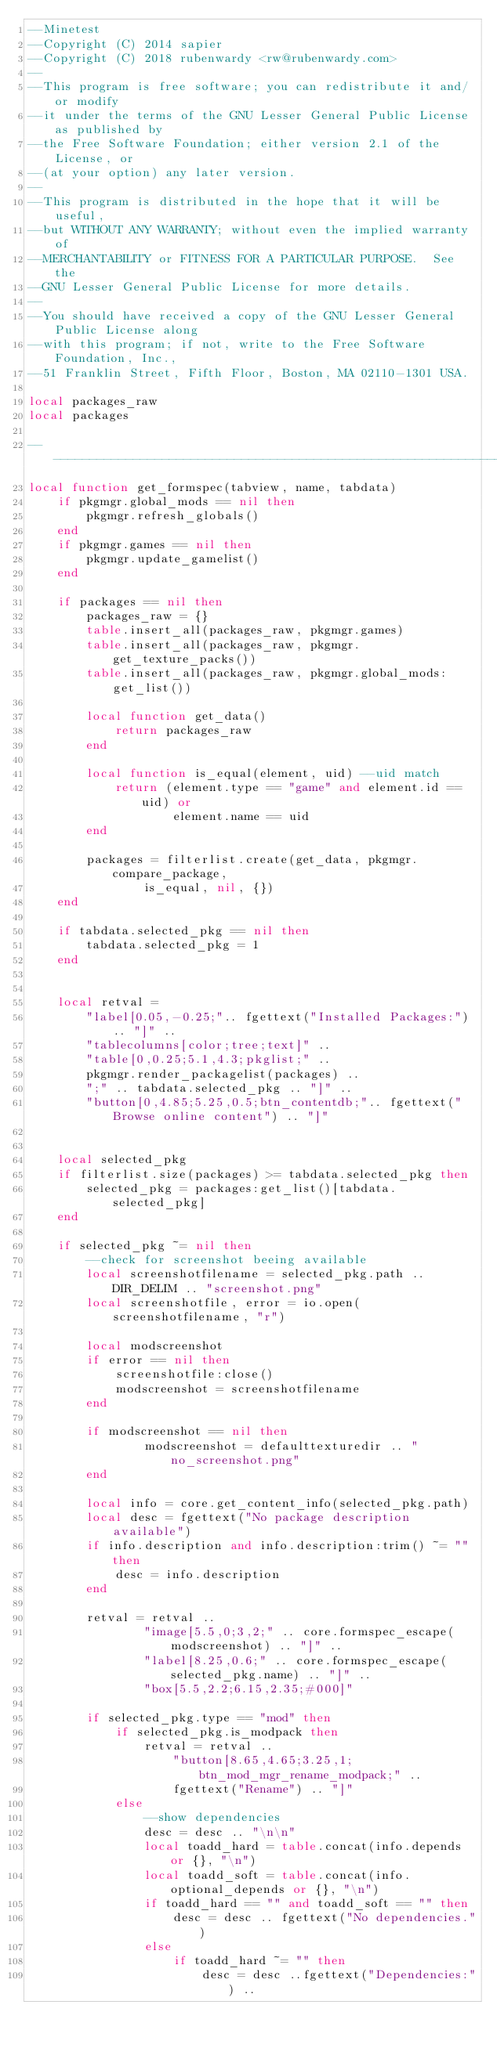Convert code to text. <code><loc_0><loc_0><loc_500><loc_500><_Lua_>--Minetest
--Copyright (C) 2014 sapier
--Copyright (C) 2018 rubenwardy <rw@rubenwardy.com>
--
--This program is free software; you can redistribute it and/or modify
--it under the terms of the GNU Lesser General Public License as published by
--the Free Software Foundation; either version 2.1 of the License, or
--(at your option) any later version.
--
--This program is distributed in the hope that it will be useful,
--but WITHOUT ANY WARRANTY; without even the implied warranty of
--MERCHANTABILITY or FITNESS FOR A PARTICULAR PURPOSE.  See the
--GNU Lesser General Public License for more details.
--
--You should have received a copy of the GNU Lesser General Public License along
--with this program; if not, write to the Free Software Foundation, Inc.,
--51 Franklin Street, Fifth Floor, Boston, MA 02110-1301 USA.

local packages_raw
local packages

--------------------------------------------------------------------------------
local function get_formspec(tabview, name, tabdata)
	if pkgmgr.global_mods == nil then
		pkgmgr.refresh_globals()
	end
	if pkgmgr.games == nil then
		pkgmgr.update_gamelist()
	end

	if packages == nil then
		packages_raw = {}
		table.insert_all(packages_raw, pkgmgr.games)
		table.insert_all(packages_raw, pkgmgr.get_texture_packs())
		table.insert_all(packages_raw, pkgmgr.global_mods:get_list())

		local function get_data()
			return packages_raw
		end

		local function is_equal(element, uid) --uid match
			return (element.type == "game" and element.id == uid) or
					element.name == uid
		end

		packages = filterlist.create(get_data, pkgmgr.compare_package,
				is_equal, nil, {})
	end

	if tabdata.selected_pkg == nil then
		tabdata.selected_pkg = 1
	end


	local retval =
		"label[0.05,-0.25;".. fgettext("Installed Packages:") .. "]" ..
		"tablecolumns[color;tree;text]" ..
		"table[0,0.25;5.1,4.3;pkglist;" ..
		pkgmgr.render_packagelist(packages) ..
		";" .. tabdata.selected_pkg .. "]" ..
		"button[0,4.85;5.25,0.5;btn_contentdb;".. fgettext("Browse online content") .. "]"


	local selected_pkg
	if filterlist.size(packages) >= tabdata.selected_pkg then
		selected_pkg = packages:get_list()[tabdata.selected_pkg]
	end

	if selected_pkg ~= nil then
		--check for screenshot beeing available
		local screenshotfilename = selected_pkg.path .. DIR_DELIM .. "screenshot.png"
		local screenshotfile, error = io.open(screenshotfilename, "r")

		local modscreenshot
		if error == nil then
			screenshotfile:close()
			modscreenshot = screenshotfilename
		end

		if modscreenshot == nil then
				modscreenshot = defaulttexturedir .. "no_screenshot.png"
		end

		local info = core.get_content_info(selected_pkg.path)
		local desc = fgettext("No package description available")
		if info.description and info.description:trim() ~= "" then
			desc = info.description
		end

		retval = retval ..
				"image[5.5,0;3,2;" .. core.formspec_escape(modscreenshot) .. "]" ..
				"label[8.25,0.6;" .. core.formspec_escape(selected_pkg.name) .. "]" ..
				"box[5.5,2.2;6.15,2.35;#000]"

		if selected_pkg.type == "mod" then
			if selected_pkg.is_modpack then
				retval = retval ..
					"button[8.65,4.65;3.25,1;btn_mod_mgr_rename_modpack;" ..
					fgettext("Rename") .. "]"
			else
				--show dependencies
				desc = desc .. "\n\n"
				local toadd_hard = table.concat(info.depends or {}, "\n")
				local toadd_soft = table.concat(info.optional_depends or {}, "\n")
				if toadd_hard == "" and toadd_soft == "" then
					desc = desc .. fgettext("No dependencies.")
				else
					if toadd_hard ~= "" then
						desc = desc ..fgettext("Dependencies:") ..</code> 